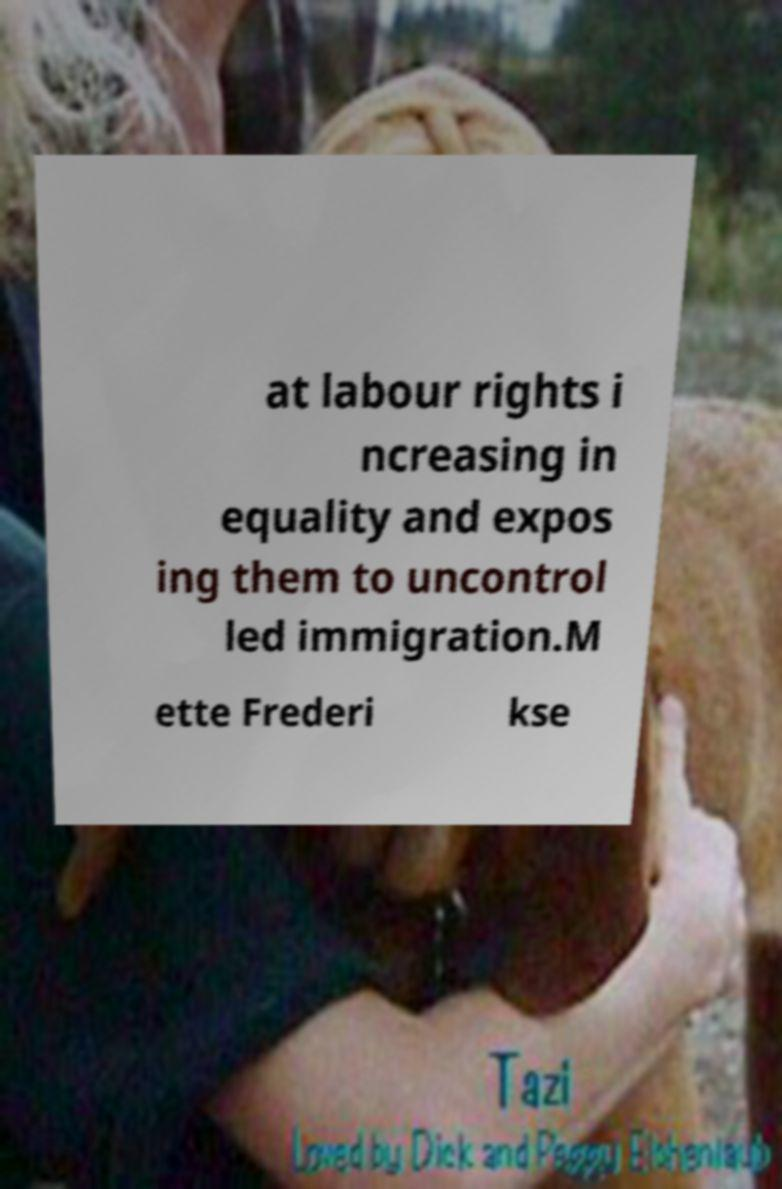Please identify and transcribe the text found in this image. at labour rights i ncreasing in equality and expos ing them to uncontrol led immigration.M ette Frederi kse 